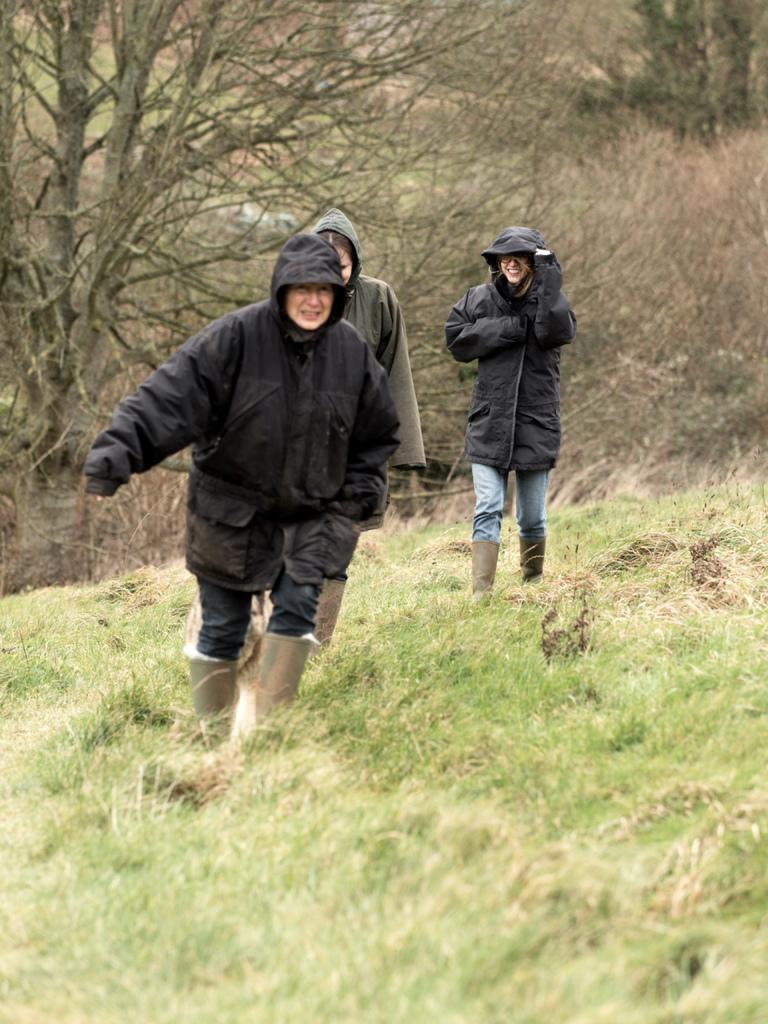How many women are present in the image? There are three women in the image. What are the women wearing? The women are wearing black coats. What are the women doing in the image? The women are walking on a grass hill. What can be seen in the background of the image? There are many dry trees in the background of the image. What type of surprise can be seen in the image? There is no surprise present in the image; it features three women walking on a grass hill with dry trees in the background. 